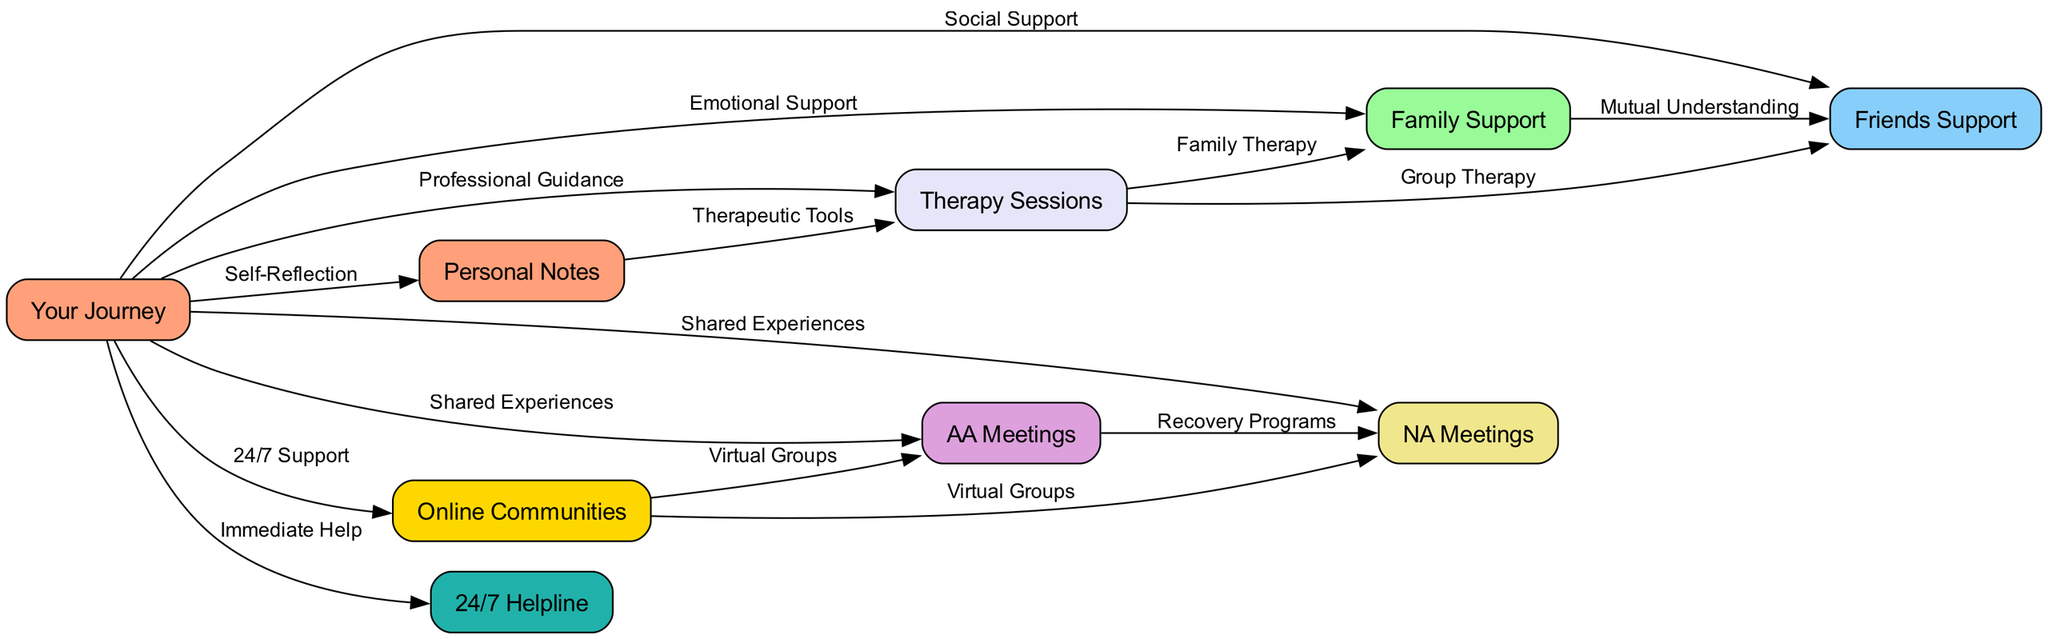What is the total number of nodes in the diagram? The diagram includes eight unique nodes, which represent various support groups and resources related to recovery.
Answer: 8 What is the label of the node directly connected to "Your Journey" providing "Immediate Help"? "Your Journey" connects directly to the "24/7 Helpline," which serves as an immediate resource for support when needed.
Answer: 24/7 Helpline How many connections (edges) are there from "Your Journey" to other nodes? "Your Journey" is connected to seven other nodes, indicating various forms of support available regarding recovery.
Answer: 7 What label is shared between the "AA Meetings" and the "NA Meetings"? Both "AA Meetings" and "NA Meetings" are linked by the label "Shared Experiences," highlighting the commonality in the recovery process they each facilitate.
Answer: Shared Experiences Which node relates to "Family Support" through "Family Therapy"? "Family Support" is linked to "Therapy Sessions" with the label "Family Therapy," indicating a connection in therapeutic settings focused on familial relationships during recovery.
Answer: Therapy Sessions What type of support is represented by the connection from "Your Journey" to "Online Communities"? The connection from "Your Journey" to "Online Communities" is labeled "24/7 Support," emphasizing the continuous access to community support available online.
Answer: 24/7 Support How many nodes are indicated as providing a form of support based on shared experiences? There are three nodes connected by shared experiences: "AA Meetings," "NA Meetings," and "Your Journey," which discuss the similar paths taken during recovery.
Answer: 3 What support method connects "Friends Support" to "Therapy Sessions"? The relationship from "Friends Support" to "Therapy Sessions" is labeled "Group Therapy," which involves friends participating in a therapeutic setting together.
Answer: Group Therapy Which node is identified as a resource for "Self-Reflection"? The "Personal Notes" node is identified as a resource for "Self-Reflection," indicating its role in helping individuals evaluate their own journeys.
Answer: Personal Notes 